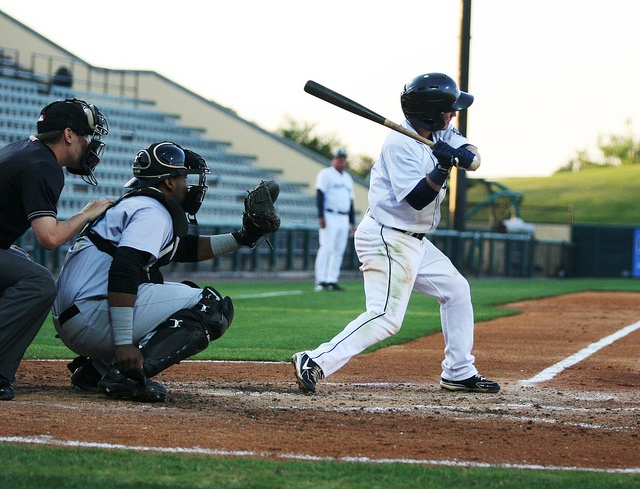Describe the objects in this image and their specific colors. I can see people in white, black, and gray tones, people in white, lavender, black, lightblue, and darkgray tones, people in white, black, gray, and navy tones, people in white, lightblue, lavender, and gray tones, and baseball glove in white, black, purple, and gray tones in this image. 